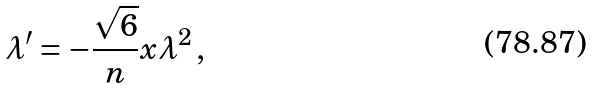Convert formula to latex. <formula><loc_0><loc_0><loc_500><loc_500>\lambda ^ { \prime } = - \frac { \sqrt { 6 } } { n } x \lambda ^ { 2 } \, ,</formula> 